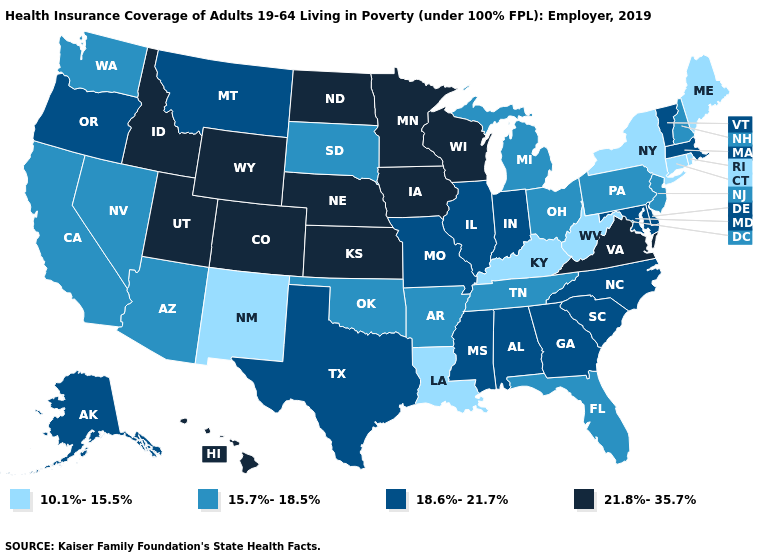How many symbols are there in the legend?
Write a very short answer. 4. Is the legend a continuous bar?
Give a very brief answer. No. Name the states that have a value in the range 21.8%-35.7%?
Quick response, please. Colorado, Hawaii, Idaho, Iowa, Kansas, Minnesota, Nebraska, North Dakota, Utah, Virginia, Wisconsin, Wyoming. Does Illinois have the lowest value in the USA?
Quick response, please. No. What is the value of Missouri?
Keep it brief. 18.6%-21.7%. Which states hav the highest value in the Northeast?
Be succinct. Massachusetts, Vermont. What is the highest value in the South ?
Short answer required. 21.8%-35.7%. What is the value of Vermont?
Give a very brief answer. 18.6%-21.7%. What is the highest value in the USA?
Give a very brief answer. 21.8%-35.7%. What is the lowest value in states that border North Carolina?
Short answer required. 15.7%-18.5%. Name the states that have a value in the range 10.1%-15.5%?
Answer briefly. Connecticut, Kentucky, Louisiana, Maine, New Mexico, New York, Rhode Island, West Virginia. What is the value of Arizona?
Give a very brief answer. 15.7%-18.5%. What is the lowest value in the USA?
Answer briefly. 10.1%-15.5%. Is the legend a continuous bar?
Be succinct. No. What is the value of Maine?
Answer briefly. 10.1%-15.5%. 